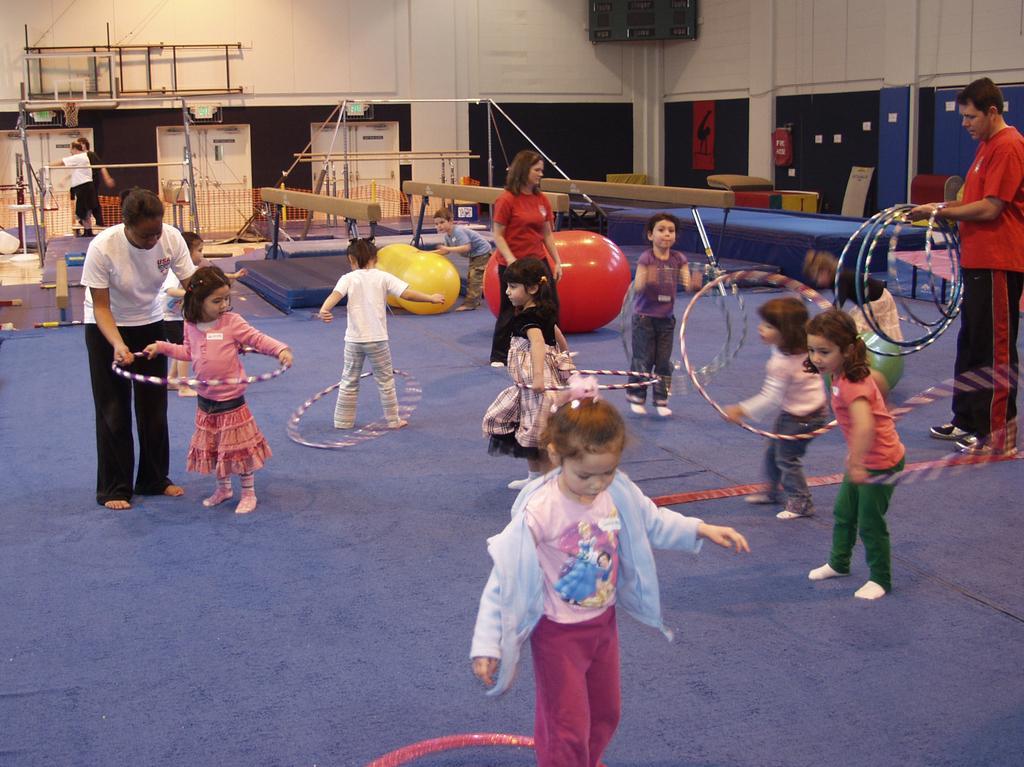Could you give a brief overview of what you see in this image? In this image we can see a group of people standing on the floor. Some children are holding rings with their hands. On the right side of the image we can see a man holding hula hoop in his hand and some containers placed on the ground. In the background, we can see group of balls and stands are placed on the floor, group of doors and a screen on the wall. 